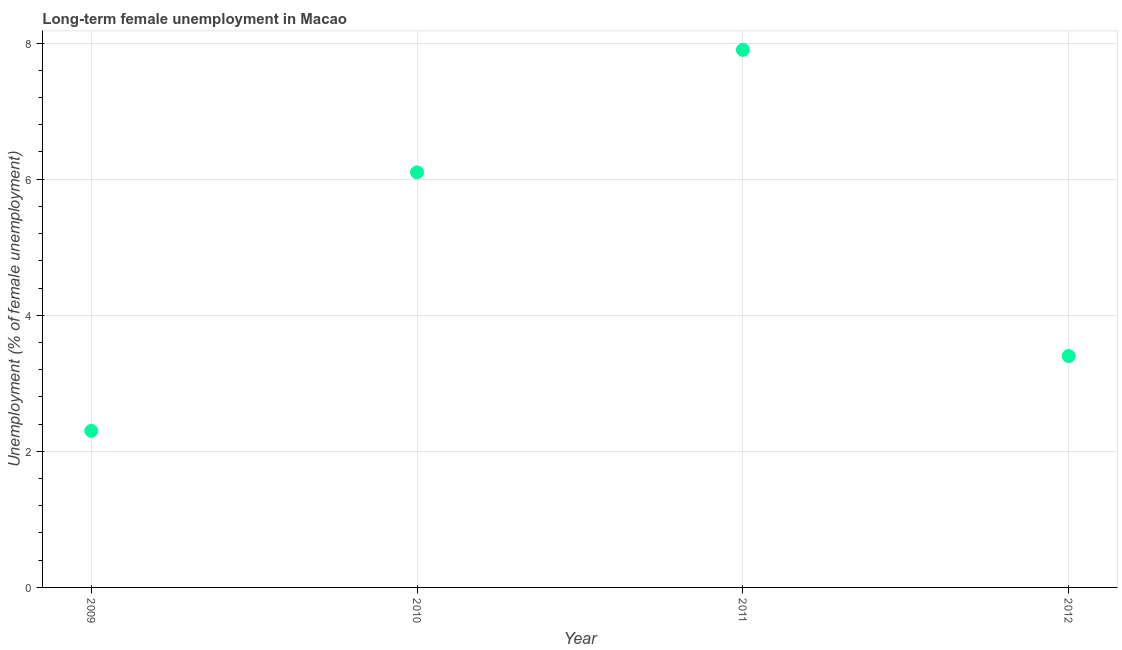What is the long-term female unemployment in 2010?
Provide a short and direct response. 6.1. Across all years, what is the maximum long-term female unemployment?
Make the answer very short. 7.9. Across all years, what is the minimum long-term female unemployment?
Keep it short and to the point. 2.3. In which year was the long-term female unemployment minimum?
Your answer should be compact. 2009. What is the sum of the long-term female unemployment?
Keep it short and to the point. 19.7. What is the difference between the long-term female unemployment in 2011 and 2012?
Offer a very short reply. 4.5. What is the average long-term female unemployment per year?
Your answer should be very brief. 4.93. What is the median long-term female unemployment?
Ensure brevity in your answer.  4.75. What is the ratio of the long-term female unemployment in 2009 to that in 2010?
Your response must be concise. 0.38. What is the difference between the highest and the second highest long-term female unemployment?
Give a very brief answer. 1.8. What is the difference between the highest and the lowest long-term female unemployment?
Your answer should be compact. 5.6. How many dotlines are there?
Give a very brief answer. 1. How many years are there in the graph?
Provide a short and direct response. 4. What is the title of the graph?
Offer a very short reply. Long-term female unemployment in Macao. What is the label or title of the Y-axis?
Offer a very short reply. Unemployment (% of female unemployment). What is the Unemployment (% of female unemployment) in 2009?
Ensure brevity in your answer.  2.3. What is the Unemployment (% of female unemployment) in 2010?
Make the answer very short. 6.1. What is the Unemployment (% of female unemployment) in 2011?
Offer a terse response. 7.9. What is the Unemployment (% of female unemployment) in 2012?
Keep it short and to the point. 3.4. What is the difference between the Unemployment (% of female unemployment) in 2009 and 2012?
Make the answer very short. -1.1. What is the difference between the Unemployment (% of female unemployment) in 2010 and 2011?
Your answer should be very brief. -1.8. What is the difference between the Unemployment (% of female unemployment) in 2011 and 2012?
Offer a very short reply. 4.5. What is the ratio of the Unemployment (% of female unemployment) in 2009 to that in 2010?
Make the answer very short. 0.38. What is the ratio of the Unemployment (% of female unemployment) in 2009 to that in 2011?
Your response must be concise. 0.29. What is the ratio of the Unemployment (% of female unemployment) in 2009 to that in 2012?
Make the answer very short. 0.68. What is the ratio of the Unemployment (% of female unemployment) in 2010 to that in 2011?
Offer a terse response. 0.77. What is the ratio of the Unemployment (% of female unemployment) in 2010 to that in 2012?
Ensure brevity in your answer.  1.79. What is the ratio of the Unemployment (% of female unemployment) in 2011 to that in 2012?
Give a very brief answer. 2.32. 